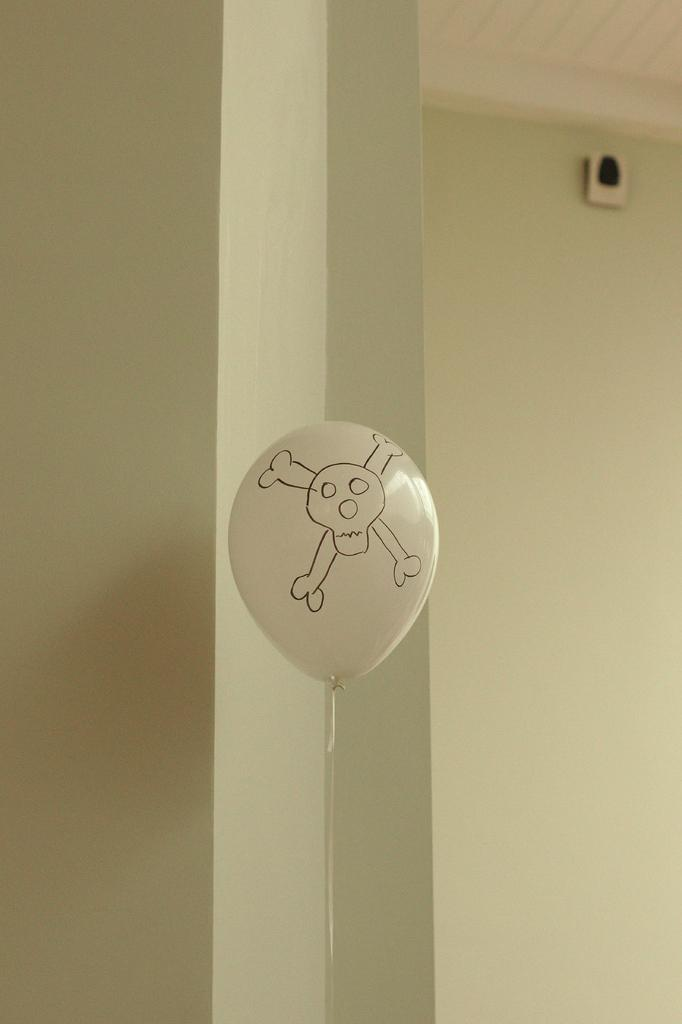What object with a specific design can be seen in the image? There is a balloon in the image, and it has a skull image on it. What type of surface is present in the image? There is a wall in the image. What device for playing music is visible in the image? There is a speaker in the image. What part of the room can be seen in the image? The ceiling is visible in the image. What type of pie is being served on the table in the image? There is no table or pie present in the image; it only features a balloon, wall, speaker, and ceiling. What kind of watch is the toad wearing in the image? There is no toad or watch present in the image. 